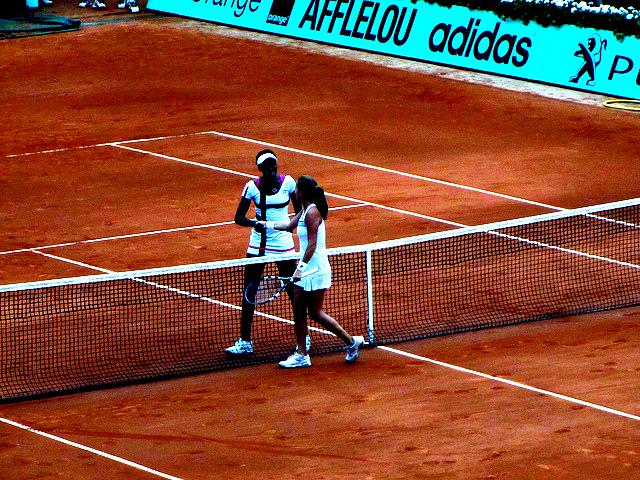What can you infer about the setting and time of the event? The image shows an outdoor clay tennis court, which is characteristic of certain prestigious tournaments, possibly indicating this match is part of a professional event. The presence of sponsor banners and the attire of the players also point to a formal competition. As for the time, the shadows suggest it could be late afternoon or early evening. 